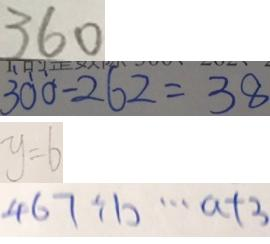Convert formula to latex. <formula><loc_0><loc_0><loc_500><loc_500>3 6 0 
 3 0 0 - 2 6 2 = 3 8 
 y = 6 
 4 6 7 \div b \cdots a + 3</formula> 